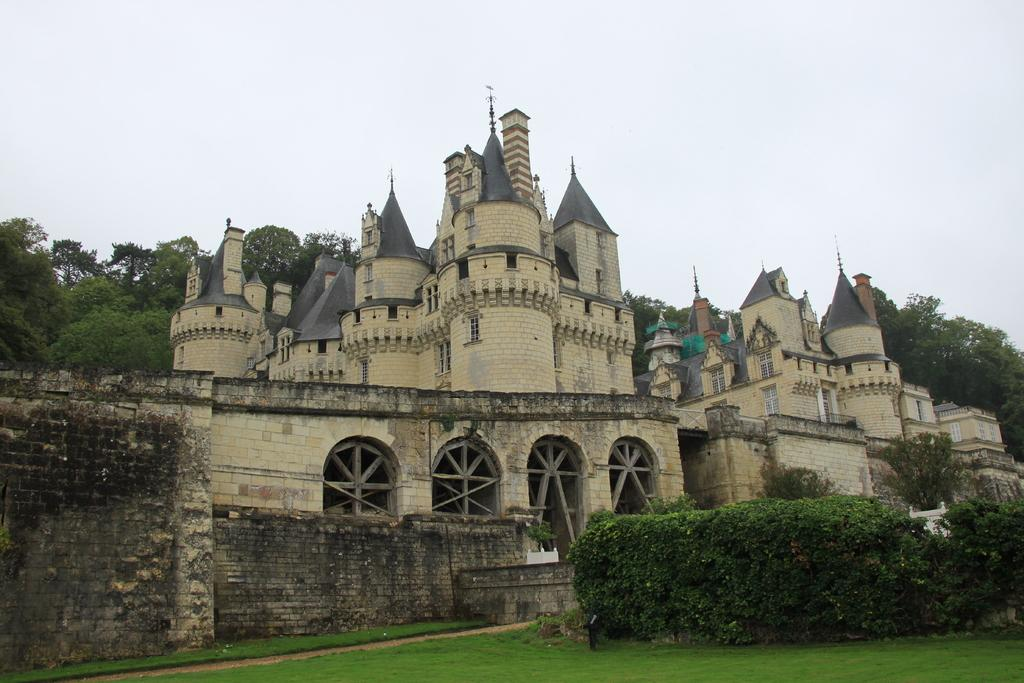What type of structures can be seen in the image? There are buildings in the image. What architectural features are visible in the image? There are windows and walls visible in the image. What type of vegetation is present in the image? There are plants, grass, and trees in the image. What part of the natural environment is visible in the image? The sky is visible in the image. Can you tell me how many veins are visible in the image? There are no veins present in the image; it features buildings, windows, walls, plants, grass, trees, and the sky. What type of creature is shown interacting with the governor in the image? There is no governor or creature shown interacting in the image; it only features buildings, windows, walls, plants, grass, trees, and the sky. 